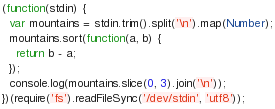<code> <loc_0><loc_0><loc_500><loc_500><_JavaScript_>(function(stdin) {
  var mountains = stdin.trim().split('\n').map(Number);
  mountains.sort(function(a, b) {
    return b - a;
  });
  console.log(mountains.slice(0, 3).join('\n'));
})(require('fs').readFileSync('/dev/stdin', 'utf8'));</code> 